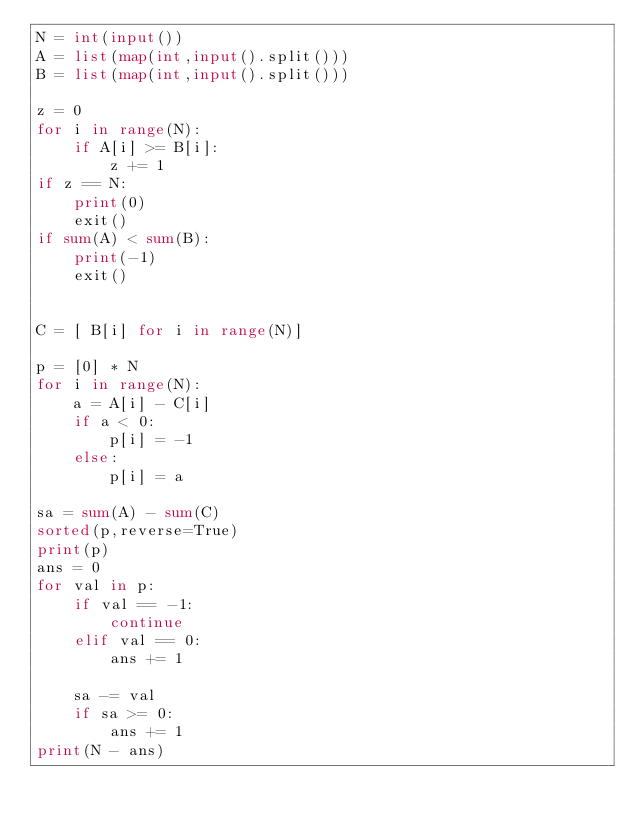<code> <loc_0><loc_0><loc_500><loc_500><_Python_>N = int(input())
A = list(map(int,input().split()))
B = list(map(int,input().split()))

z = 0
for i in range(N):
    if A[i] >= B[i]:
        z += 1
if z == N:
    print(0)
    exit()
if sum(A) < sum(B):
    print(-1)
    exit()


C = [ B[i] for i in range(N)]

p = [0] * N
for i in range(N):
    a = A[i] - C[i]
    if a < 0:
        p[i] = -1
    else:
        p[i] = a

sa = sum(A) - sum(C)
sorted(p,reverse=True)
print(p)
ans = 0
for val in p:
    if val == -1:
        continue
    elif val == 0:
        ans += 1

    sa -= val
    if sa >= 0:
        ans += 1
print(N - ans)
</code> 